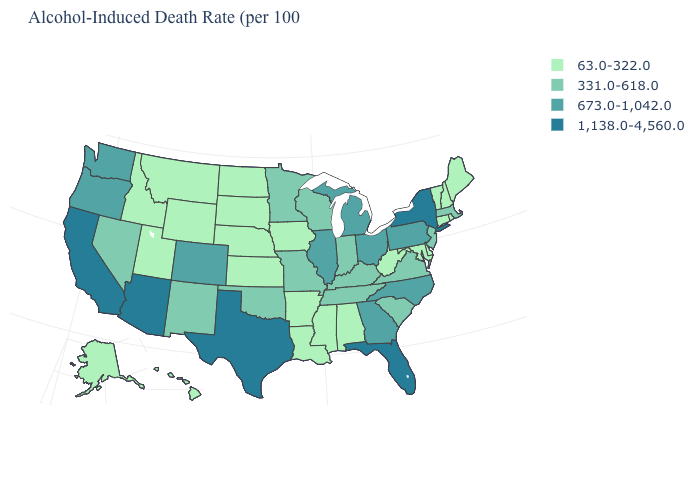How many symbols are there in the legend?
Write a very short answer. 4. What is the value of Louisiana?
Answer briefly. 63.0-322.0. What is the value of Maine?
Short answer required. 63.0-322.0. Among the states that border Kansas , which have the lowest value?
Be succinct. Nebraska. What is the value of New Mexico?
Quick response, please. 331.0-618.0. How many symbols are there in the legend?
Short answer required. 4. How many symbols are there in the legend?
Write a very short answer. 4. What is the highest value in the USA?
Quick response, please. 1,138.0-4,560.0. What is the value of Hawaii?
Write a very short answer. 63.0-322.0. What is the value of Indiana?
Write a very short answer. 331.0-618.0. Does Iowa have a lower value than Montana?
Give a very brief answer. No. Does the map have missing data?
Give a very brief answer. No. What is the value of New Hampshire?
Be succinct. 63.0-322.0. Which states hav the highest value in the South?
Be succinct. Florida, Texas. Does Vermont have the lowest value in the Northeast?
Quick response, please. Yes. 